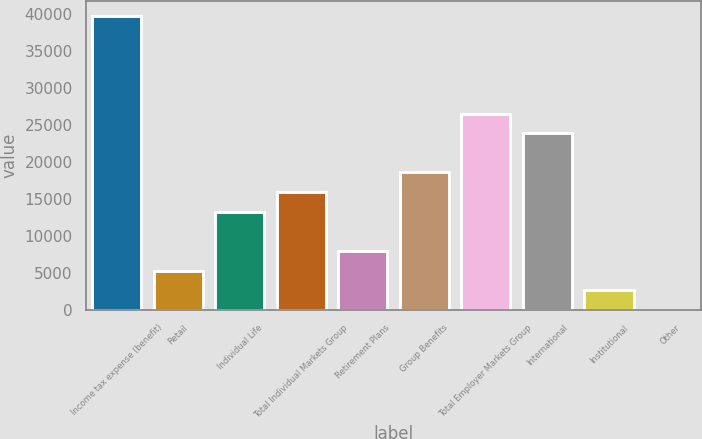Convert chart to OTSL. <chart><loc_0><loc_0><loc_500><loc_500><bar_chart><fcel>Income tax expense (benefit)<fcel>Retail<fcel>Individual Life<fcel>Total Individual Markets Group<fcel>Retirement Plans<fcel>Group Benefits<fcel>Total Employer Markets Group<fcel>International<fcel>Institutional<fcel>Other<nl><fcel>39739.5<fcel>5316.8<fcel>13260.5<fcel>15908.4<fcel>7964.7<fcel>18556.3<fcel>26500<fcel>23852.1<fcel>2668.9<fcel>21<nl></chart> 